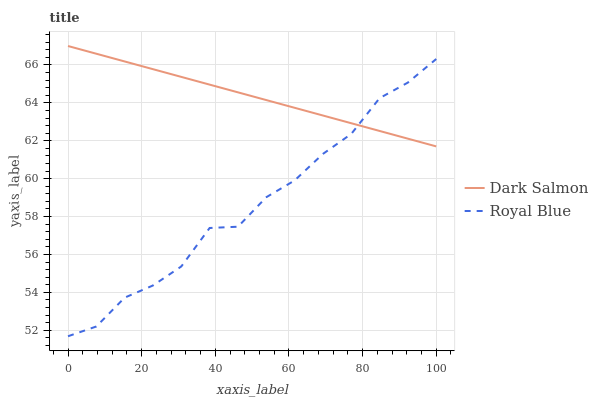Does Royal Blue have the minimum area under the curve?
Answer yes or no. Yes. Does Dark Salmon have the maximum area under the curve?
Answer yes or no. Yes. Does Dark Salmon have the minimum area under the curve?
Answer yes or no. No. Is Dark Salmon the smoothest?
Answer yes or no. Yes. Is Royal Blue the roughest?
Answer yes or no. Yes. Is Dark Salmon the roughest?
Answer yes or no. No. Does Royal Blue have the lowest value?
Answer yes or no. Yes. Does Dark Salmon have the lowest value?
Answer yes or no. No. Does Dark Salmon have the highest value?
Answer yes or no. Yes. Does Royal Blue intersect Dark Salmon?
Answer yes or no. Yes. Is Royal Blue less than Dark Salmon?
Answer yes or no. No. Is Royal Blue greater than Dark Salmon?
Answer yes or no. No. 